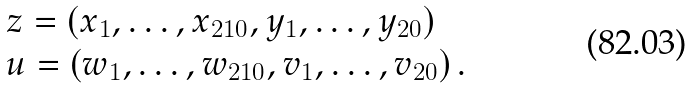Convert formula to latex. <formula><loc_0><loc_0><loc_500><loc_500>\begin{array} { l l } { z } = ( x _ { 1 } , \dots , x _ { 2 1 0 } , y _ { 1 } , \dots , y _ { 2 0 } ) \\ { u } = ( w _ { 1 } , \dots , w _ { 2 1 0 } , v _ { 1 } , \dots , v _ { 2 0 } ) \, . \end{array}</formula> 